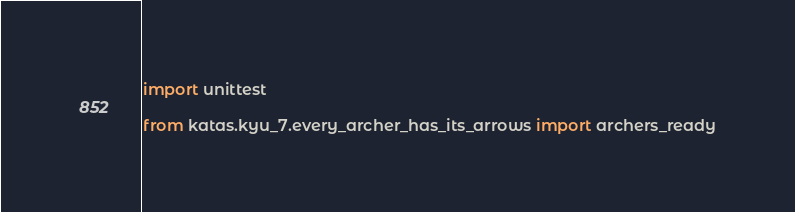<code> <loc_0><loc_0><loc_500><loc_500><_Python_>import unittest

from katas.kyu_7.every_archer_has_its_arrows import archers_ready

</code> 